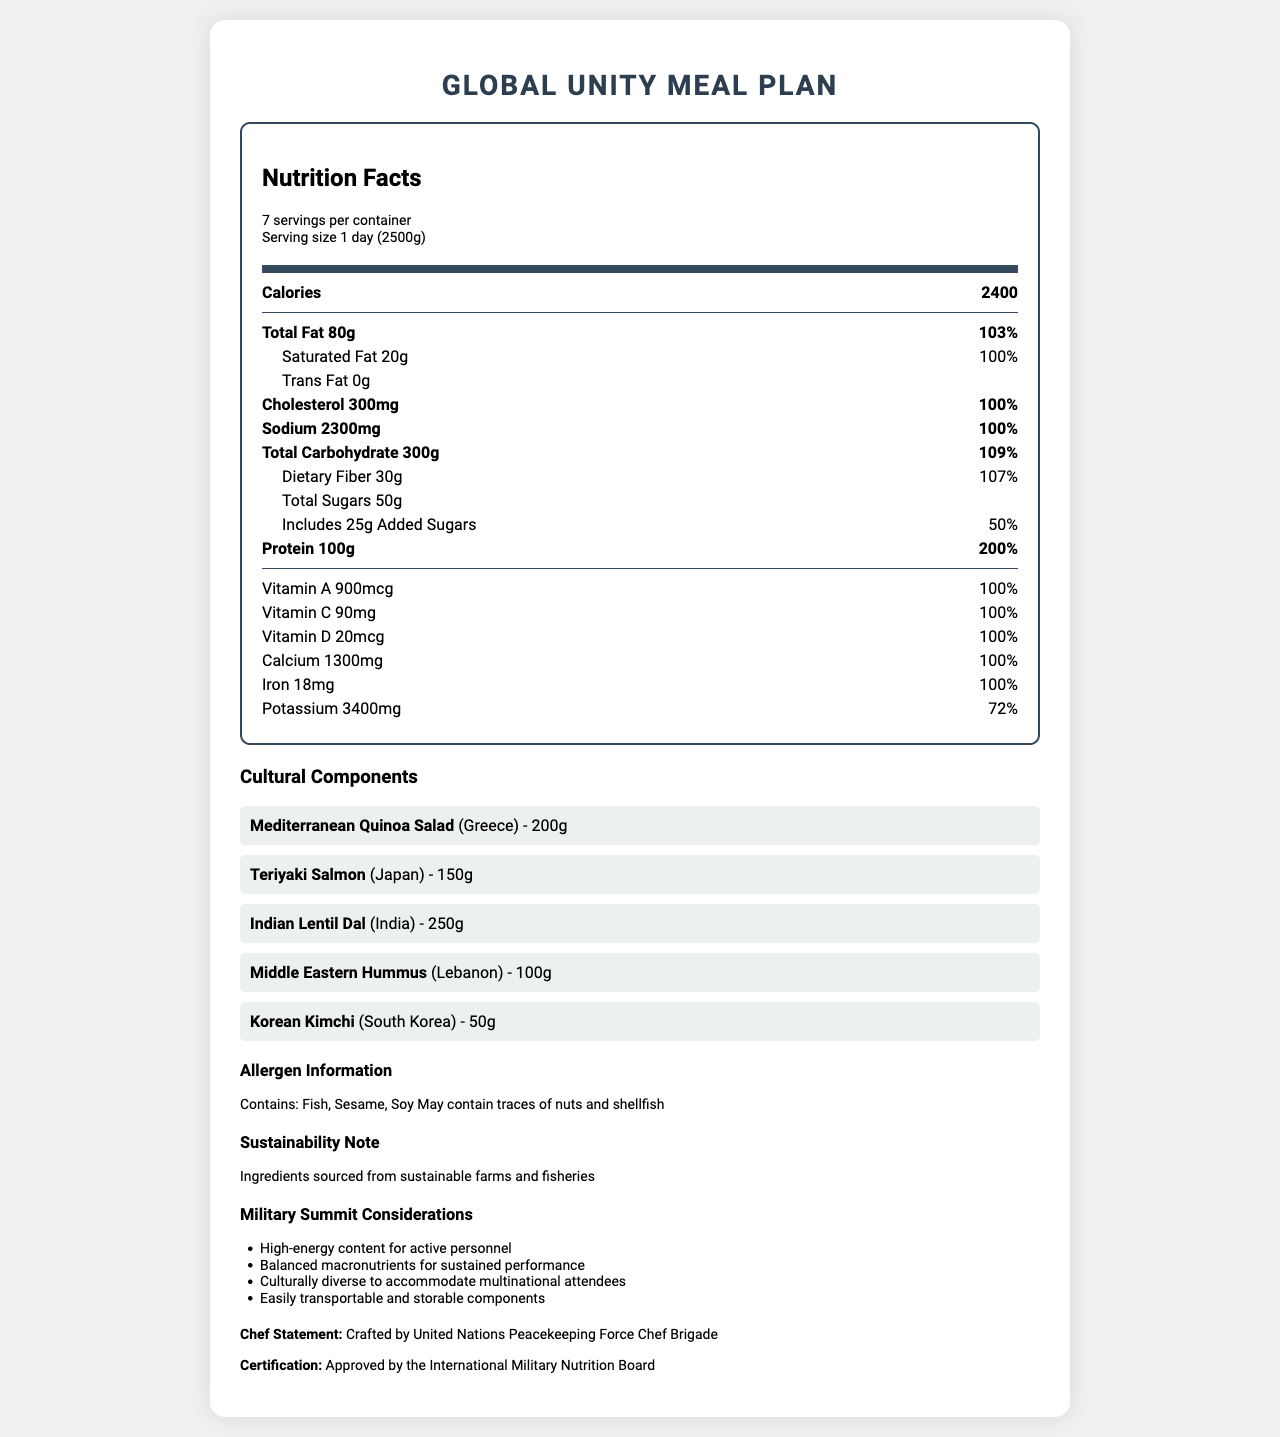what is the serving size for the Global Unity Meal Plan? The serving size is listed as "1 day (2500g)" in the document.
Answer: 1 day (2500g) How many servings per container are there? The document states that there are 7 servings per container.
Answer: 7 How many calories does one serving contain? The calories per serving are listed as 2400.
Answer: 2400 What is the amount of protein per serving and its daily value percentage? The document lists protein as 100g which is 200% of the daily value.
Answer: 100g, 200% Which cultural dish is from Greece and what is its serving size? The document states that the Mediterranean Quinoa Salad is from Greece and has a serving size of 200g.
Answer: Mediterranean Quinoa Salad, 200g Which of the following is not listed as an allergen? A. Fish B. Sesame C. Nuts D. Shellfish E. Dairy The allergen information includes Fish, Sesame, and Soy, and mentions that it may contain traces of nuts and shellfish, but dairy is not listed.
Answer: E. Dairy Which vitamin is present in the highest amount? A. Vitamin A B. Vitamin C C. Vitamin D D. Calcium The document lists Vitamin A as 900mcg (100% DV), which is higher in quantity compared to the other vitamins listed.
Answer: A. Vitamin A Is the product certified by an international body? The document states the meal plan is approved by the International Military Nutrition Board.
Answer: Yes Summarize the main purpose of this document. The document outlines nutritional information, emphasizes cultural diversity in meal components, includes allergen information, sustainability notes, and considerations for military use, highlighting both its nutritional adequacy and logistic practicality.
Answer: The document provides detailed nutrition facts, cultural components, and other considerations for a balanced, culturally diverse meal plan designed for multinational military summits. The meal is intended to meet the nutritional needs of active personnel and is certified by an international nutrition board. What is the main protein source among the cultural components listed? The document lists cultural dishes but does not specify the protein content of each dish.
Answer: Cannot be determined What is the sustainability note mentioned in the document? The document includes a section stating that ingredients are sourced from sustainable farms and fisheries.
Answer: Ingredients sourced from sustainable farms and fisheries How many grams of saturated fat are there and what percentage of the daily value does this represent? The document indicates there are 20g of saturated fat, which is 100% of the daily value.
Answer: 20g, 100% Which dish is of South Korean origin and what is its serving size? A. Teriyaki Salmon, 150g B. Indian Lentil Dal, 250g C. Korean Kimchi, 50g D. Middle Eastern Hummus, 100g The document states that Korean Kimchi is from South Korea with a serving size of 50g.
Answer: C. Korean Kimchi, 50g 